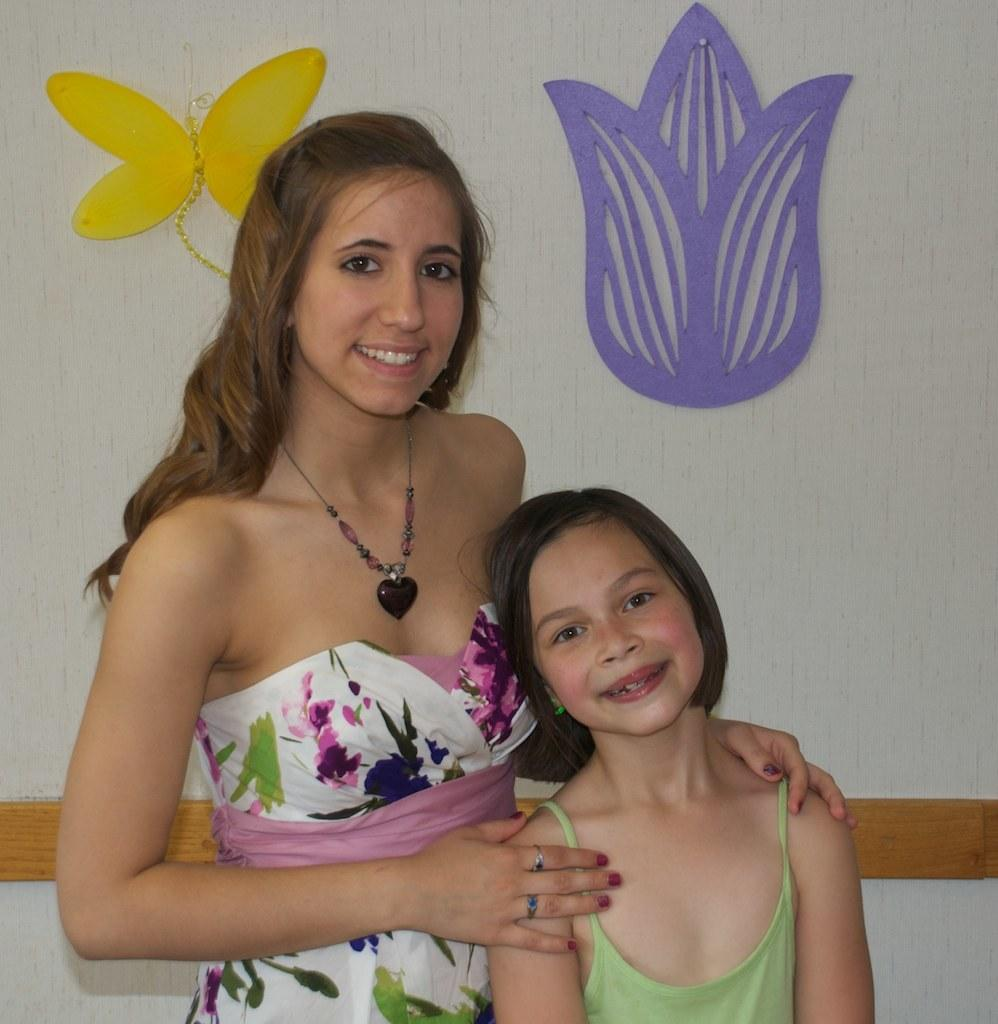Who is present in the image? There is a woman and a kid in the image. What are the expressions of the woman and the kid? The woman and the kid are both smiling. What are the woman and the kid doing in the image? The woman and the kid are standing. What can be seen in the background of the image? There is a wall with decorative items and a wooden object in the background. Can you tell me how many beams the donkey is carrying in the image? There is no donkey present in the image, and therefore no beams can be observed. 